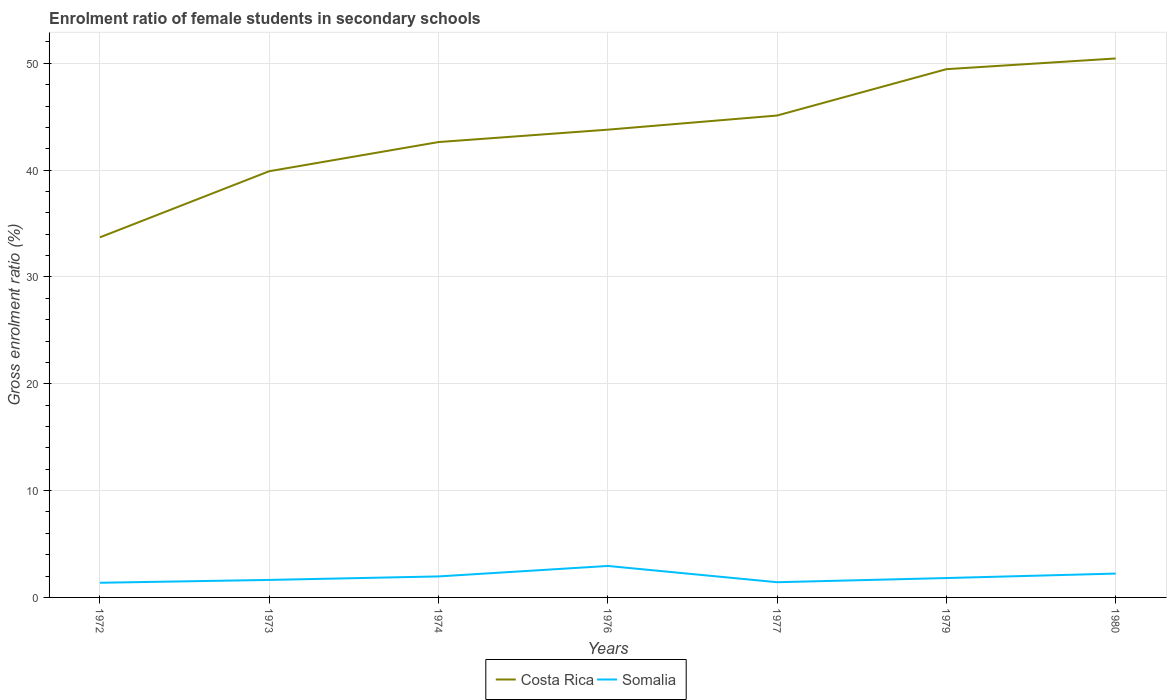Is the number of lines equal to the number of legend labels?
Keep it short and to the point. Yes. Across all years, what is the maximum enrolment ratio of female students in secondary schools in Costa Rica?
Offer a very short reply. 33.71. In which year was the enrolment ratio of female students in secondary schools in Costa Rica maximum?
Give a very brief answer. 1972. What is the total enrolment ratio of female students in secondary schools in Somalia in the graph?
Provide a succinct answer. -1.57. What is the difference between the highest and the second highest enrolment ratio of female students in secondary schools in Costa Rica?
Your response must be concise. 16.75. What is the difference between the highest and the lowest enrolment ratio of female students in secondary schools in Somalia?
Offer a terse response. 3. How many years are there in the graph?
Ensure brevity in your answer.  7. What is the difference between two consecutive major ticks on the Y-axis?
Your answer should be very brief. 10. Are the values on the major ticks of Y-axis written in scientific E-notation?
Your response must be concise. No. Does the graph contain any zero values?
Your answer should be very brief. No. Does the graph contain grids?
Provide a short and direct response. Yes. Where does the legend appear in the graph?
Offer a very short reply. Bottom center. How many legend labels are there?
Give a very brief answer. 2. How are the legend labels stacked?
Provide a succinct answer. Horizontal. What is the title of the graph?
Ensure brevity in your answer.  Enrolment ratio of female students in secondary schools. What is the label or title of the X-axis?
Give a very brief answer. Years. What is the Gross enrolment ratio (%) in Costa Rica in 1972?
Your answer should be compact. 33.71. What is the Gross enrolment ratio (%) of Somalia in 1972?
Provide a short and direct response. 1.37. What is the Gross enrolment ratio (%) of Costa Rica in 1973?
Provide a succinct answer. 39.9. What is the Gross enrolment ratio (%) of Somalia in 1973?
Ensure brevity in your answer.  1.64. What is the Gross enrolment ratio (%) of Costa Rica in 1974?
Your answer should be compact. 42.63. What is the Gross enrolment ratio (%) of Somalia in 1974?
Give a very brief answer. 1.97. What is the Gross enrolment ratio (%) of Costa Rica in 1976?
Give a very brief answer. 43.79. What is the Gross enrolment ratio (%) in Somalia in 1976?
Offer a terse response. 2.95. What is the Gross enrolment ratio (%) in Costa Rica in 1977?
Your answer should be compact. 45.11. What is the Gross enrolment ratio (%) of Somalia in 1977?
Your answer should be very brief. 1.42. What is the Gross enrolment ratio (%) in Costa Rica in 1979?
Give a very brief answer. 49.45. What is the Gross enrolment ratio (%) of Somalia in 1979?
Provide a succinct answer. 1.81. What is the Gross enrolment ratio (%) of Costa Rica in 1980?
Offer a terse response. 50.46. What is the Gross enrolment ratio (%) of Somalia in 1980?
Make the answer very short. 2.23. Across all years, what is the maximum Gross enrolment ratio (%) of Costa Rica?
Keep it short and to the point. 50.46. Across all years, what is the maximum Gross enrolment ratio (%) of Somalia?
Offer a terse response. 2.95. Across all years, what is the minimum Gross enrolment ratio (%) of Costa Rica?
Your response must be concise. 33.71. Across all years, what is the minimum Gross enrolment ratio (%) in Somalia?
Offer a terse response. 1.37. What is the total Gross enrolment ratio (%) in Costa Rica in the graph?
Your answer should be compact. 305.06. What is the total Gross enrolment ratio (%) of Somalia in the graph?
Your response must be concise. 13.39. What is the difference between the Gross enrolment ratio (%) in Costa Rica in 1972 and that in 1973?
Your answer should be very brief. -6.19. What is the difference between the Gross enrolment ratio (%) in Somalia in 1972 and that in 1973?
Ensure brevity in your answer.  -0.27. What is the difference between the Gross enrolment ratio (%) of Costa Rica in 1972 and that in 1974?
Your answer should be compact. -8.92. What is the difference between the Gross enrolment ratio (%) in Somalia in 1972 and that in 1974?
Keep it short and to the point. -0.59. What is the difference between the Gross enrolment ratio (%) in Costa Rica in 1972 and that in 1976?
Give a very brief answer. -10.08. What is the difference between the Gross enrolment ratio (%) in Somalia in 1972 and that in 1976?
Provide a short and direct response. -1.57. What is the difference between the Gross enrolment ratio (%) in Costa Rica in 1972 and that in 1977?
Your answer should be compact. -11.4. What is the difference between the Gross enrolment ratio (%) in Somalia in 1972 and that in 1977?
Offer a terse response. -0.05. What is the difference between the Gross enrolment ratio (%) of Costa Rica in 1972 and that in 1979?
Make the answer very short. -15.74. What is the difference between the Gross enrolment ratio (%) in Somalia in 1972 and that in 1979?
Offer a terse response. -0.44. What is the difference between the Gross enrolment ratio (%) in Costa Rica in 1972 and that in 1980?
Offer a terse response. -16.75. What is the difference between the Gross enrolment ratio (%) in Somalia in 1972 and that in 1980?
Provide a short and direct response. -0.86. What is the difference between the Gross enrolment ratio (%) in Costa Rica in 1973 and that in 1974?
Ensure brevity in your answer.  -2.73. What is the difference between the Gross enrolment ratio (%) in Somalia in 1973 and that in 1974?
Provide a short and direct response. -0.33. What is the difference between the Gross enrolment ratio (%) of Costa Rica in 1973 and that in 1976?
Provide a short and direct response. -3.89. What is the difference between the Gross enrolment ratio (%) in Somalia in 1973 and that in 1976?
Make the answer very short. -1.31. What is the difference between the Gross enrolment ratio (%) in Costa Rica in 1973 and that in 1977?
Make the answer very short. -5.21. What is the difference between the Gross enrolment ratio (%) of Somalia in 1973 and that in 1977?
Ensure brevity in your answer.  0.22. What is the difference between the Gross enrolment ratio (%) of Costa Rica in 1973 and that in 1979?
Offer a very short reply. -9.55. What is the difference between the Gross enrolment ratio (%) of Somalia in 1973 and that in 1979?
Offer a terse response. -0.17. What is the difference between the Gross enrolment ratio (%) of Costa Rica in 1973 and that in 1980?
Give a very brief answer. -10.56. What is the difference between the Gross enrolment ratio (%) of Somalia in 1973 and that in 1980?
Offer a terse response. -0.59. What is the difference between the Gross enrolment ratio (%) in Costa Rica in 1974 and that in 1976?
Offer a very short reply. -1.16. What is the difference between the Gross enrolment ratio (%) in Somalia in 1974 and that in 1976?
Keep it short and to the point. -0.98. What is the difference between the Gross enrolment ratio (%) of Costa Rica in 1974 and that in 1977?
Offer a terse response. -2.48. What is the difference between the Gross enrolment ratio (%) in Somalia in 1974 and that in 1977?
Ensure brevity in your answer.  0.54. What is the difference between the Gross enrolment ratio (%) of Costa Rica in 1974 and that in 1979?
Provide a succinct answer. -6.82. What is the difference between the Gross enrolment ratio (%) of Somalia in 1974 and that in 1979?
Provide a succinct answer. 0.15. What is the difference between the Gross enrolment ratio (%) in Costa Rica in 1974 and that in 1980?
Offer a terse response. -7.83. What is the difference between the Gross enrolment ratio (%) of Somalia in 1974 and that in 1980?
Your answer should be very brief. -0.27. What is the difference between the Gross enrolment ratio (%) in Costa Rica in 1976 and that in 1977?
Provide a succinct answer. -1.32. What is the difference between the Gross enrolment ratio (%) of Somalia in 1976 and that in 1977?
Your answer should be very brief. 1.52. What is the difference between the Gross enrolment ratio (%) in Costa Rica in 1976 and that in 1979?
Your response must be concise. -5.66. What is the difference between the Gross enrolment ratio (%) of Somalia in 1976 and that in 1979?
Your response must be concise. 1.13. What is the difference between the Gross enrolment ratio (%) of Costa Rica in 1976 and that in 1980?
Provide a short and direct response. -6.67. What is the difference between the Gross enrolment ratio (%) of Somalia in 1976 and that in 1980?
Give a very brief answer. 0.71. What is the difference between the Gross enrolment ratio (%) in Costa Rica in 1977 and that in 1979?
Your response must be concise. -4.34. What is the difference between the Gross enrolment ratio (%) of Somalia in 1977 and that in 1979?
Provide a short and direct response. -0.39. What is the difference between the Gross enrolment ratio (%) in Costa Rica in 1977 and that in 1980?
Your answer should be very brief. -5.34. What is the difference between the Gross enrolment ratio (%) in Somalia in 1977 and that in 1980?
Offer a very short reply. -0.81. What is the difference between the Gross enrolment ratio (%) of Costa Rica in 1979 and that in 1980?
Your response must be concise. -1. What is the difference between the Gross enrolment ratio (%) of Somalia in 1979 and that in 1980?
Keep it short and to the point. -0.42. What is the difference between the Gross enrolment ratio (%) of Costa Rica in 1972 and the Gross enrolment ratio (%) of Somalia in 1973?
Offer a very short reply. 32.07. What is the difference between the Gross enrolment ratio (%) of Costa Rica in 1972 and the Gross enrolment ratio (%) of Somalia in 1974?
Ensure brevity in your answer.  31.75. What is the difference between the Gross enrolment ratio (%) in Costa Rica in 1972 and the Gross enrolment ratio (%) in Somalia in 1976?
Offer a very short reply. 30.76. What is the difference between the Gross enrolment ratio (%) in Costa Rica in 1972 and the Gross enrolment ratio (%) in Somalia in 1977?
Your response must be concise. 32.29. What is the difference between the Gross enrolment ratio (%) in Costa Rica in 1972 and the Gross enrolment ratio (%) in Somalia in 1979?
Your answer should be compact. 31.9. What is the difference between the Gross enrolment ratio (%) in Costa Rica in 1972 and the Gross enrolment ratio (%) in Somalia in 1980?
Give a very brief answer. 31.48. What is the difference between the Gross enrolment ratio (%) of Costa Rica in 1973 and the Gross enrolment ratio (%) of Somalia in 1974?
Provide a succinct answer. 37.94. What is the difference between the Gross enrolment ratio (%) in Costa Rica in 1973 and the Gross enrolment ratio (%) in Somalia in 1976?
Provide a short and direct response. 36.95. What is the difference between the Gross enrolment ratio (%) of Costa Rica in 1973 and the Gross enrolment ratio (%) of Somalia in 1977?
Your response must be concise. 38.48. What is the difference between the Gross enrolment ratio (%) of Costa Rica in 1973 and the Gross enrolment ratio (%) of Somalia in 1979?
Provide a short and direct response. 38.09. What is the difference between the Gross enrolment ratio (%) of Costa Rica in 1973 and the Gross enrolment ratio (%) of Somalia in 1980?
Offer a very short reply. 37.67. What is the difference between the Gross enrolment ratio (%) in Costa Rica in 1974 and the Gross enrolment ratio (%) in Somalia in 1976?
Provide a short and direct response. 39.68. What is the difference between the Gross enrolment ratio (%) of Costa Rica in 1974 and the Gross enrolment ratio (%) of Somalia in 1977?
Offer a very short reply. 41.21. What is the difference between the Gross enrolment ratio (%) in Costa Rica in 1974 and the Gross enrolment ratio (%) in Somalia in 1979?
Your answer should be very brief. 40.82. What is the difference between the Gross enrolment ratio (%) in Costa Rica in 1974 and the Gross enrolment ratio (%) in Somalia in 1980?
Your answer should be compact. 40.4. What is the difference between the Gross enrolment ratio (%) in Costa Rica in 1976 and the Gross enrolment ratio (%) in Somalia in 1977?
Your answer should be very brief. 42.37. What is the difference between the Gross enrolment ratio (%) of Costa Rica in 1976 and the Gross enrolment ratio (%) of Somalia in 1979?
Make the answer very short. 41.98. What is the difference between the Gross enrolment ratio (%) of Costa Rica in 1976 and the Gross enrolment ratio (%) of Somalia in 1980?
Offer a very short reply. 41.56. What is the difference between the Gross enrolment ratio (%) of Costa Rica in 1977 and the Gross enrolment ratio (%) of Somalia in 1979?
Keep it short and to the point. 43.3. What is the difference between the Gross enrolment ratio (%) of Costa Rica in 1977 and the Gross enrolment ratio (%) of Somalia in 1980?
Your response must be concise. 42.88. What is the difference between the Gross enrolment ratio (%) in Costa Rica in 1979 and the Gross enrolment ratio (%) in Somalia in 1980?
Your answer should be very brief. 47.22. What is the average Gross enrolment ratio (%) of Costa Rica per year?
Make the answer very short. 43.58. What is the average Gross enrolment ratio (%) in Somalia per year?
Ensure brevity in your answer.  1.91. In the year 1972, what is the difference between the Gross enrolment ratio (%) of Costa Rica and Gross enrolment ratio (%) of Somalia?
Offer a terse response. 32.34. In the year 1973, what is the difference between the Gross enrolment ratio (%) of Costa Rica and Gross enrolment ratio (%) of Somalia?
Give a very brief answer. 38.26. In the year 1974, what is the difference between the Gross enrolment ratio (%) of Costa Rica and Gross enrolment ratio (%) of Somalia?
Your answer should be compact. 40.66. In the year 1976, what is the difference between the Gross enrolment ratio (%) of Costa Rica and Gross enrolment ratio (%) of Somalia?
Keep it short and to the point. 40.84. In the year 1977, what is the difference between the Gross enrolment ratio (%) in Costa Rica and Gross enrolment ratio (%) in Somalia?
Provide a succinct answer. 43.69. In the year 1979, what is the difference between the Gross enrolment ratio (%) in Costa Rica and Gross enrolment ratio (%) in Somalia?
Offer a very short reply. 47.64. In the year 1980, what is the difference between the Gross enrolment ratio (%) in Costa Rica and Gross enrolment ratio (%) in Somalia?
Make the answer very short. 48.22. What is the ratio of the Gross enrolment ratio (%) of Costa Rica in 1972 to that in 1973?
Provide a short and direct response. 0.84. What is the ratio of the Gross enrolment ratio (%) of Somalia in 1972 to that in 1973?
Offer a very short reply. 0.84. What is the ratio of the Gross enrolment ratio (%) of Costa Rica in 1972 to that in 1974?
Offer a terse response. 0.79. What is the ratio of the Gross enrolment ratio (%) in Somalia in 1972 to that in 1974?
Your answer should be very brief. 0.7. What is the ratio of the Gross enrolment ratio (%) of Costa Rica in 1972 to that in 1976?
Provide a short and direct response. 0.77. What is the ratio of the Gross enrolment ratio (%) of Somalia in 1972 to that in 1976?
Offer a terse response. 0.47. What is the ratio of the Gross enrolment ratio (%) of Costa Rica in 1972 to that in 1977?
Make the answer very short. 0.75. What is the ratio of the Gross enrolment ratio (%) of Costa Rica in 1972 to that in 1979?
Your answer should be very brief. 0.68. What is the ratio of the Gross enrolment ratio (%) in Somalia in 1972 to that in 1979?
Ensure brevity in your answer.  0.76. What is the ratio of the Gross enrolment ratio (%) of Costa Rica in 1972 to that in 1980?
Offer a very short reply. 0.67. What is the ratio of the Gross enrolment ratio (%) in Somalia in 1972 to that in 1980?
Offer a very short reply. 0.61. What is the ratio of the Gross enrolment ratio (%) of Costa Rica in 1973 to that in 1974?
Your answer should be compact. 0.94. What is the ratio of the Gross enrolment ratio (%) of Somalia in 1973 to that in 1974?
Your answer should be compact. 0.83. What is the ratio of the Gross enrolment ratio (%) in Costa Rica in 1973 to that in 1976?
Your answer should be compact. 0.91. What is the ratio of the Gross enrolment ratio (%) of Somalia in 1973 to that in 1976?
Ensure brevity in your answer.  0.56. What is the ratio of the Gross enrolment ratio (%) in Costa Rica in 1973 to that in 1977?
Offer a very short reply. 0.88. What is the ratio of the Gross enrolment ratio (%) in Somalia in 1973 to that in 1977?
Provide a succinct answer. 1.15. What is the ratio of the Gross enrolment ratio (%) of Costa Rica in 1973 to that in 1979?
Give a very brief answer. 0.81. What is the ratio of the Gross enrolment ratio (%) of Somalia in 1973 to that in 1979?
Provide a succinct answer. 0.9. What is the ratio of the Gross enrolment ratio (%) of Costa Rica in 1973 to that in 1980?
Your response must be concise. 0.79. What is the ratio of the Gross enrolment ratio (%) in Somalia in 1973 to that in 1980?
Your answer should be very brief. 0.73. What is the ratio of the Gross enrolment ratio (%) of Costa Rica in 1974 to that in 1976?
Keep it short and to the point. 0.97. What is the ratio of the Gross enrolment ratio (%) of Somalia in 1974 to that in 1976?
Your answer should be very brief. 0.67. What is the ratio of the Gross enrolment ratio (%) in Costa Rica in 1974 to that in 1977?
Your answer should be compact. 0.94. What is the ratio of the Gross enrolment ratio (%) of Somalia in 1974 to that in 1977?
Your answer should be compact. 1.38. What is the ratio of the Gross enrolment ratio (%) in Costa Rica in 1974 to that in 1979?
Provide a short and direct response. 0.86. What is the ratio of the Gross enrolment ratio (%) of Somalia in 1974 to that in 1979?
Your answer should be compact. 1.08. What is the ratio of the Gross enrolment ratio (%) of Costa Rica in 1974 to that in 1980?
Make the answer very short. 0.84. What is the ratio of the Gross enrolment ratio (%) in Somalia in 1974 to that in 1980?
Offer a terse response. 0.88. What is the ratio of the Gross enrolment ratio (%) in Costa Rica in 1976 to that in 1977?
Your answer should be very brief. 0.97. What is the ratio of the Gross enrolment ratio (%) in Somalia in 1976 to that in 1977?
Offer a terse response. 2.07. What is the ratio of the Gross enrolment ratio (%) in Costa Rica in 1976 to that in 1979?
Make the answer very short. 0.89. What is the ratio of the Gross enrolment ratio (%) of Somalia in 1976 to that in 1979?
Give a very brief answer. 1.62. What is the ratio of the Gross enrolment ratio (%) in Costa Rica in 1976 to that in 1980?
Your response must be concise. 0.87. What is the ratio of the Gross enrolment ratio (%) of Somalia in 1976 to that in 1980?
Keep it short and to the point. 1.32. What is the ratio of the Gross enrolment ratio (%) in Costa Rica in 1977 to that in 1979?
Offer a terse response. 0.91. What is the ratio of the Gross enrolment ratio (%) in Somalia in 1977 to that in 1979?
Keep it short and to the point. 0.78. What is the ratio of the Gross enrolment ratio (%) in Costa Rica in 1977 to that in 1980?
Ensure brevity in your answer.  0.89. What is the ratio of the Gross enrolment ratio (%) of Somalia in 1977 to that in 1980?
Offer a terse response. 0.64. What is the ratio of the Gross enrolment ratio (%) in Costa Rica in 1979 to that in 1980?
Offer a very short reply. 0.98. What is the ratio of the Gross enrolment ratio (%) in Somalia in 1979 to that in 1980?
Provide a short and direct response. 0.81. What is the difference between the highest and the second highest Gross enrolment ratio (%) of Costa Rica?
Your response must be concise. 1. What is the difference between the highest and the second highest Gross enrolment ratio (%) of Somalia?
Keep it short and to the point. 0.71. What is the difference between the highest and the lowest Gross enrolment ratio (%) in Costa Rica?
Your response must be concise. 16.75. What is the difference between the highest and the lowest Gross enrolment ratio (%) of Somalia?
Provide a succinct answer. 1.57. 